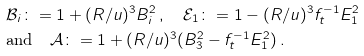<formula> <loc_0><loc_0><loc_500><loc_500>& \mathcal { B } _ { i } \colon = 1 + ( R / u ) ^ { 3 } B _ { i } ^ { 2 } \, , \quad \mathcal { E } _ { 1 } \colon = 1 - ( R / u ) ^ { 3 } f _ { t } ^ { - 1 } E _ { 1 } ^ { 2 } \\ & \text {and} \quad \mathcal { A } \colon = 1 + ( R / u ) ^ { 3 } ( B _ { 3 } ^ { 2 } - f _ { t } ^ { - 1 } E _ { 1 } ^ { 2 } ) \, .</formula> 